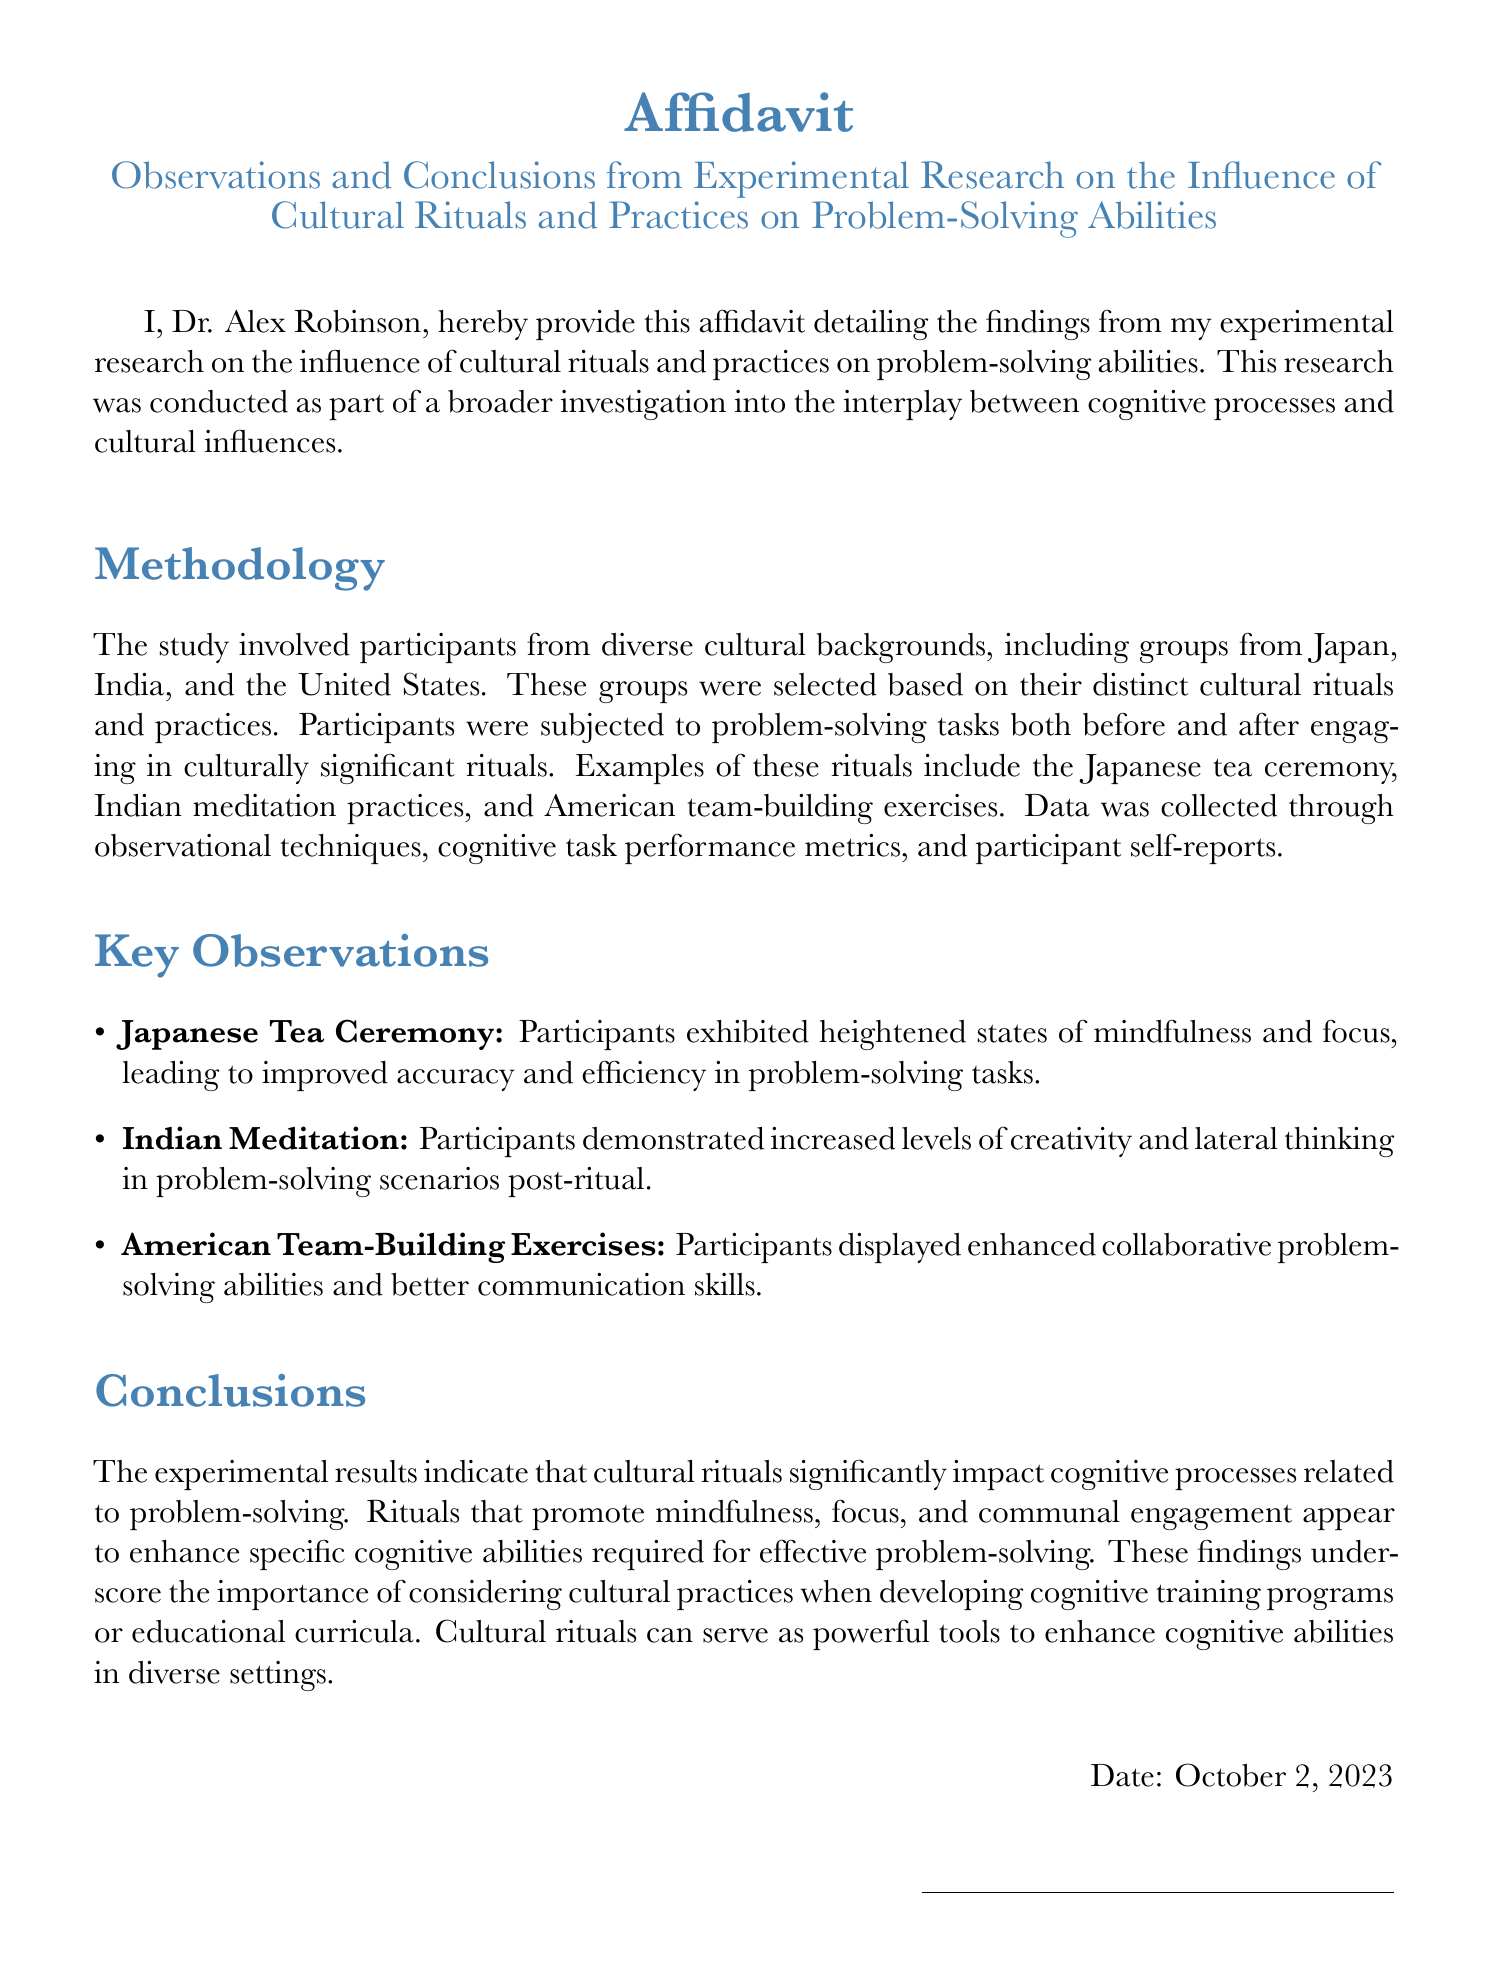What is the name of the researcher? The name of the researcher who provided the affidavit is prominently stated at the end of the document.
Answer: Dr. Alex Robinson What is the date of the affidavit? The date on which the affidavit was signed is mentioned towards the end of the document.
Answer: October 2, 2023 Which cultural ritual led to improved accuracy and efficiency? The specific observation regarding improved problem-solving abilities linked to the Japanese cultural practice is listed under key observations.
Answer: Japanese Tea Ceremony What were the participants' backgrounds? The document mentions that the research involved participants from various cultural backgrounds which are defined in the methodology section.
Answer: Japan, India, and the United States What cognitive ability increased after Indian meditation? The document states that participants demonstrated a specific type of cognitive enhancement after engaging in Indian meditation practices.
Answer: Creativity What impact did American team-building exercises have on participants? The findings regarding the effects of American team-building exercises include improvements in some abilities, as noted in the key observations.
Answer: Collaborative problem-solving abilities What type of study was conducted? The document clearly categorizes the research effort in the introduction.
Answer: Experimental research What aspect of cognitive abilities do cultural rituals enhance? The conclusions section discusses the effect of cultural rituals on specific abilities, providing insight into overall cognitive function.
Answer: Problem-solving abilities 